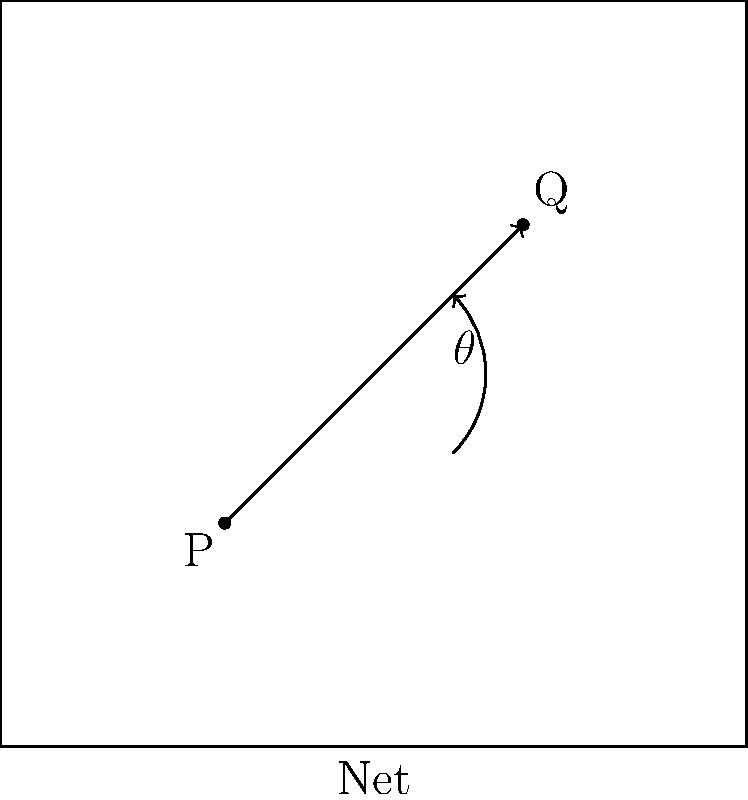In the tennis court diagram above, a player at point P is attempting a cross-court shot to reach point Q. Given that the court is a perfect square with sides of 100 units, what is the optimal angle $\theta$ (in degrees) for the shot, measured counterclockwise from the horizontal? To determine the optimal angle for the cross-court shot, we need to follow these steps:

1. Identify the coordinates of points P and Q:
   P = (30, 30)
   Q = (70, 70)

2. Calculate the difference in x and y coordinates:
   $\Delta x = 70 - 30 = 40$
   $\Delta y = 70 - 30 = 40$

3. Use the arctangent function to calculate the angle:
   $\theta = \arctan(\frac{\Delta y}{\Delta x})$

4. Substitute the values:
   $\theta = \arctan(\frac{40}{40}) = \arctan(1)$

5. Convert the result to degrees:
   $\theta = \arctan(1) \cdot \frac{180}{\pi} \approx 45°$

The optimal angle for the cross-court shot is approximately 45 degrees counterclockwise from the horizontal.
Answer: 45° 